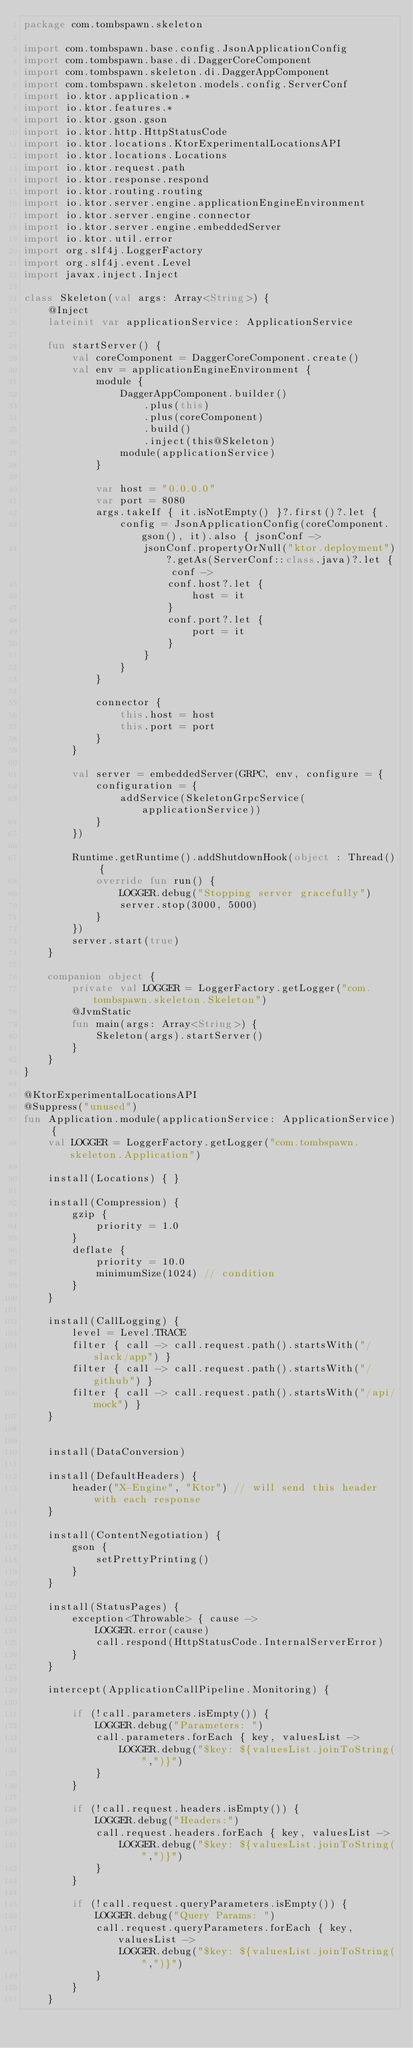Convert code to text. <code><loc_0><loc_0><loc_500><loc_500><_Kotlin_>package com.tombspawn.skeleton

import com.tombspawn.base.config.JsonApplicationConfig
import com.tombspawn.base.di.DaggerCoreComponent
import com.tombspawn.skeleton.di.DaggerAppComponent
import com.tombspawn.skeleton.models.config.ServerConf
import io.ktor.application.*
import io.ktor.features.*
import io.ktor.gson.gson
import io.ktor.http.HttpStatusCode
import io.ktor.locations.KtorExperimentalLocationsAPI
import io.ktor.locations.Locations
import io.ktor.request.path
import io.ktor.response.respond
import io.ktor.routing.routing
import io.ktor.server.engine.applicationEngineEnvironment
import io.ktor.server.engine.connector
import io.ktor.server.engine.embeddedServer
import io.ktor.util.error
import org.slf4j.LoggerFactory
import org.slf4j.event.Level
import javax.inject.Inject

class Skeleton(val args: Array<String>) {
    @Inject
    lateinit var applicationService: ApplicationService

    fun startServer() {
        val coreComponent = DaggerCoreComponent.create()
        val env = applicationEngineEnvironment {
            module {
                DaggerAppComponent.builder()
                    .plus(this)
                    .plus(coreComponent)
                    .build()
                    .inject(this@Skeleton)
                module(applicationService)
            }

            var host = "0.0.0.0"
            var port = 8080
            args.takeIf { it.isNotEmpty() }?.first()?.let {
                config = JsonApplicationConfig(coreComponent.gson(), it).also { jsonConf ->
                    jsonConf.propertyOrNull("ktor.deployment")?.getAs(ServerConf::class.java)?.let { conf ->
                        conf.host?.let {
                            host = it
                        }
                        conf.port?.let {
                            port = it
                        }
                    }
                }
            }

            connector {
                this.host = host
                this.port = port
            }
        }

        val server = embeddedServer(GRPC, env, configure = {
            configuration = {
                addService(SkeletonGrpcService(applicationService))
            }
        })

        Runtime.getRuntime().addShutdownHook(object : Thread() {
            override fun run() {
                LOGGER.debug("Stopping server gracefully")
                server.stop(3000, 5000)
            }
        })
        server.start(true)
    }

    companion object {
        private val LOGGER = LoggerFactory.getLogger("com.tombspawn.skeleton.Skeleton")
        @JvmStatic
        fun main(args: Array<String>) {
            Skeleton(args).startServer()
        }
    }
}

@KtorExperimentalLocationsAPI
@Suppress("unused")
fun Application.module(applicationService: ApplicationService) {
    val LOGGER = LoggerFactory.getLogger("com.tombspawn.skeleton.Application")

    install(Locations) { }

    install(Compression) {
        gzip {
            priority = 1.0
        }
        deflate {
            priority = 10.0
            minimumSize(1024) // condition
        }
    }

    install(CallLogging) {
        level = Level.TRACE
        filter { call -> call.request.path().startsWith("/slack/app") }
        filter { call -> call.request.path().startsWith("/github") }
        filter { call -> call.request.path().startsWith("/api/mock") }
    }


    install(DataConversion)

    install(DefaultHeaders) {
        header("X-Engine", "Ktor") // will send this header with each response
    }

    install(ContentNegotiation) {
        gson {
            setPrettyPrinting()
        }
    }

    install(StatusPages) {
        exception<Throwable> { cause ->
            LOGGER.error(cause)
            call.respond(HttpStatusCode.InternalServerError)
        }
    }

    intercept(ApplicationCallPipeline.Monitoring) {

        if (!call.parameters.isEmpty()) {
            LOGGER.debug("Parameters: ")
            call.parameters.forEach { key, valuesList ->
                LOGGER.debug("$key: ${valuesList.joinToString(",")}")
            }
        }

        if (!call.request.headers.isEmpty()) {
            LOGGER.debug("Headers:")
            call.request.headers.forEach { key, valuesList ->
                LOGGER.debug("$key: ${valuesList.joinToString(",")}")
            }
        }

        if (!call.request.queryParameters.isEmpty()) {
            LOGGER.debug("Query Params: ")
            call.request.queryParameters.forEach { key, valuesList ->
                LOGGER.debug("$key: ${valuesList.joinToString(",")}")
            }
        }
    }
</code> 